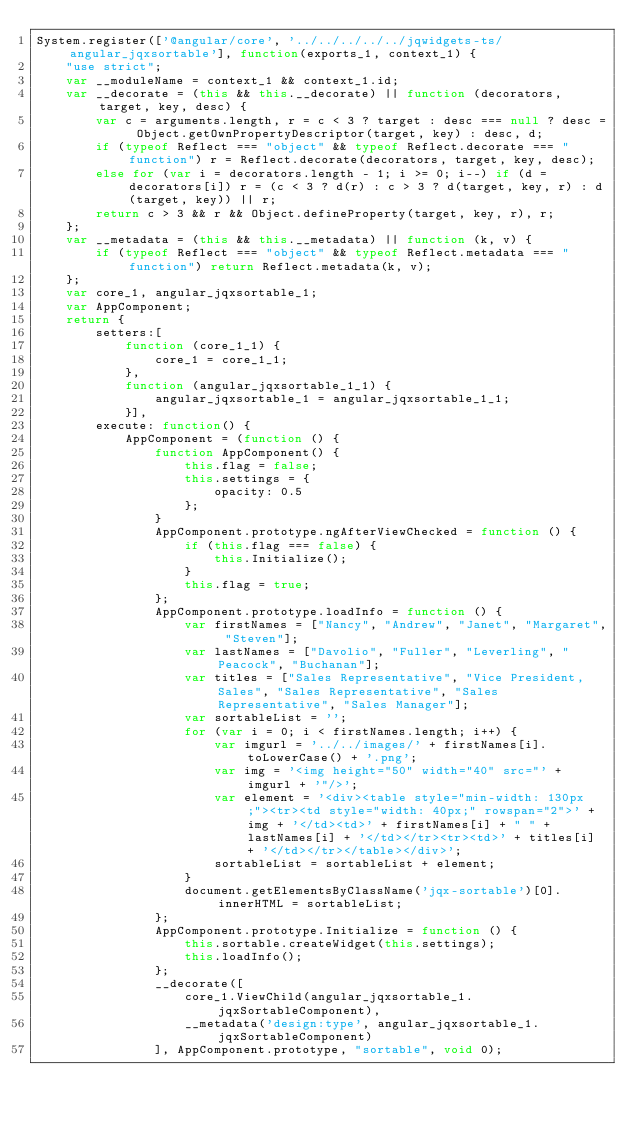<code> <loc_0><loc_0><loc_500><loc_500><_JavaScript_>System.register(['@angular/core', '../../../../../jqwidgets-ts/angular_jqxsortable'], function(exports_1, context_1) {
    "use strict";
    var __moduleName = context_1 && context_1.id;
    var __decorate = (this && this.__decorate) || function (decorators, target, key, desc) {
        var c = arguments.length, r = c < 3 ? target : desc === null ? desc = Object.getOwnPropertyDescriptor(target, key) : desc, d;
        if (typeof Reflect === "object" && typeof Reflect.decorate === "function") r = Reflect.decorate(decorators, target, key, desc);
        else for (var i = decorators.length - 1; i >= 0; i--) if (d = decorators[i]) r = (c < 3 ? d(r) : c > 3 ? d(target, key, r) : d(target, key)) || r;
        return c > 3 && r && Object.defineProperty(target, key, r), r;
    };
    var __metadata = (this && this.__metadata) || function (k, v) {
        if (typeof Reflect === "object" && typeof Reflect.metadata === "function") return Reflect.metadata(k, v);
    };
    var core_1, angular_jqxsortable_1;
    var AppComponent;
    return {
        setters:[
            function (core_1_1) {
                core_1 = core_1_1;
            },
            function (angular_jqxsortable_1_1) {
                angular_jqxsortable_1 = angular_jqxsortable_1_1;
            }],
        execute: function() {
            AppComponent = (function () {
                function AppComponent() {
                    this.flag = false;
                    this.settings = {
                        opacity: 0.5
                    };
                }
                AppComponent.prototype.ngAfterViewChecked = function () {
                    if (this.flag === false) {
                        this.Initialize();
                    }
                    this.flag = true;
                };
                AppComponent.prototype.loadInfo = function () {
                    var firstNames = ["Nancy", "Andrew", "Janet", "Margaret", "Steven"];
                    var lastNames = ["Davolio", "Fuller", "Leverling", "Peacock", "Buchanan"];
                    var titles = ["Sales Representative", "Vice President, Sales", "Sales Representative", "Sales Representative", "Sales Manager"];
                    var sortableList = '';
                    for (var i = 0; i < firstNames.length; i++) {
                        var imgurl = '../../images/' + firstNames[i].toLowerCase() + '.png';
                        var img = '<img height="50" width="40" src="' + imgurl + '"/>';
                        var element = '<div><table style="min-width: 130px;"><tr><td style="width: 40px;" rowspan="2">' + img + '</td><td>' + firstNames[i] + " " + lastNames[i] + '</td></tr><tr><td>' + titles[i] + '</td></tr></table></div>';
                        sortableList = sortableList + element;
                    }
                    document.getElementsByClassName('jqx-sortable')[0].innerHTML = sortableList;
                };
                AppComponent.prototype.Initialize = function () {
                    this.sortable.createWidget(this.settings);
                    this.loadInfo();
                };
                __decorate([
                    core_1.ViewChild(angular_jqxsortable_1.jqxSortableComponent), 
                    __metadata('design:type', angular_jqxsortable_1.jqxSortableComponent)
                ], AppComponent.prototype, "sortable", void 0);</code> 